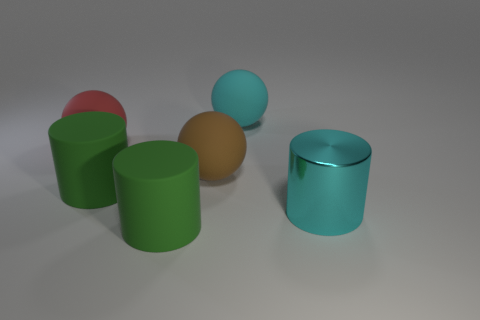Subtract 1 spheres. How many spheres are left? 2 Add 4 big cyan cylinders. How many objects exist? 10 Subtract 0 green balls. How many objects are left? 6 Subtract all big brown matte balls. Subtract all big yellow things. How many objects are left? 5 Add 3 big green rubber cylinders. How many big green rubber cylinders are left? 5 Add 6 yellow metal spheres. How many yellow metal spheres exist? 6 